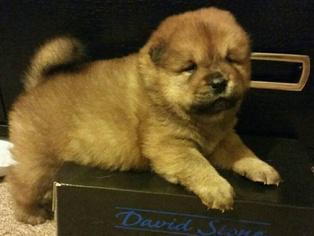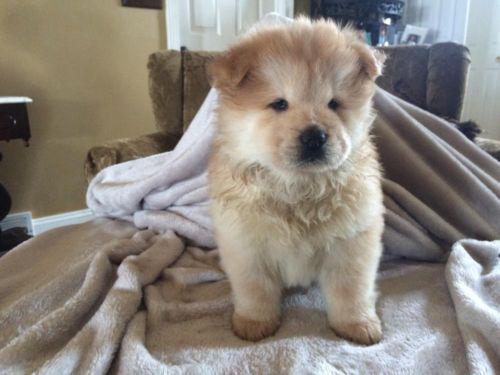The first image is the image on the left, the second image is the image on the right. Given the left and right images, does the statement "One image shows a chow dog posed in front of something with green foliage, and each image contains a single dog." hold true? Answer yes or no. No. The first image is the image on the left, the second image is the image on the right. For the images displayed, is the sentence "The dog in the image on the left is lying down." factually correct? Answer yes or no. Yes. 